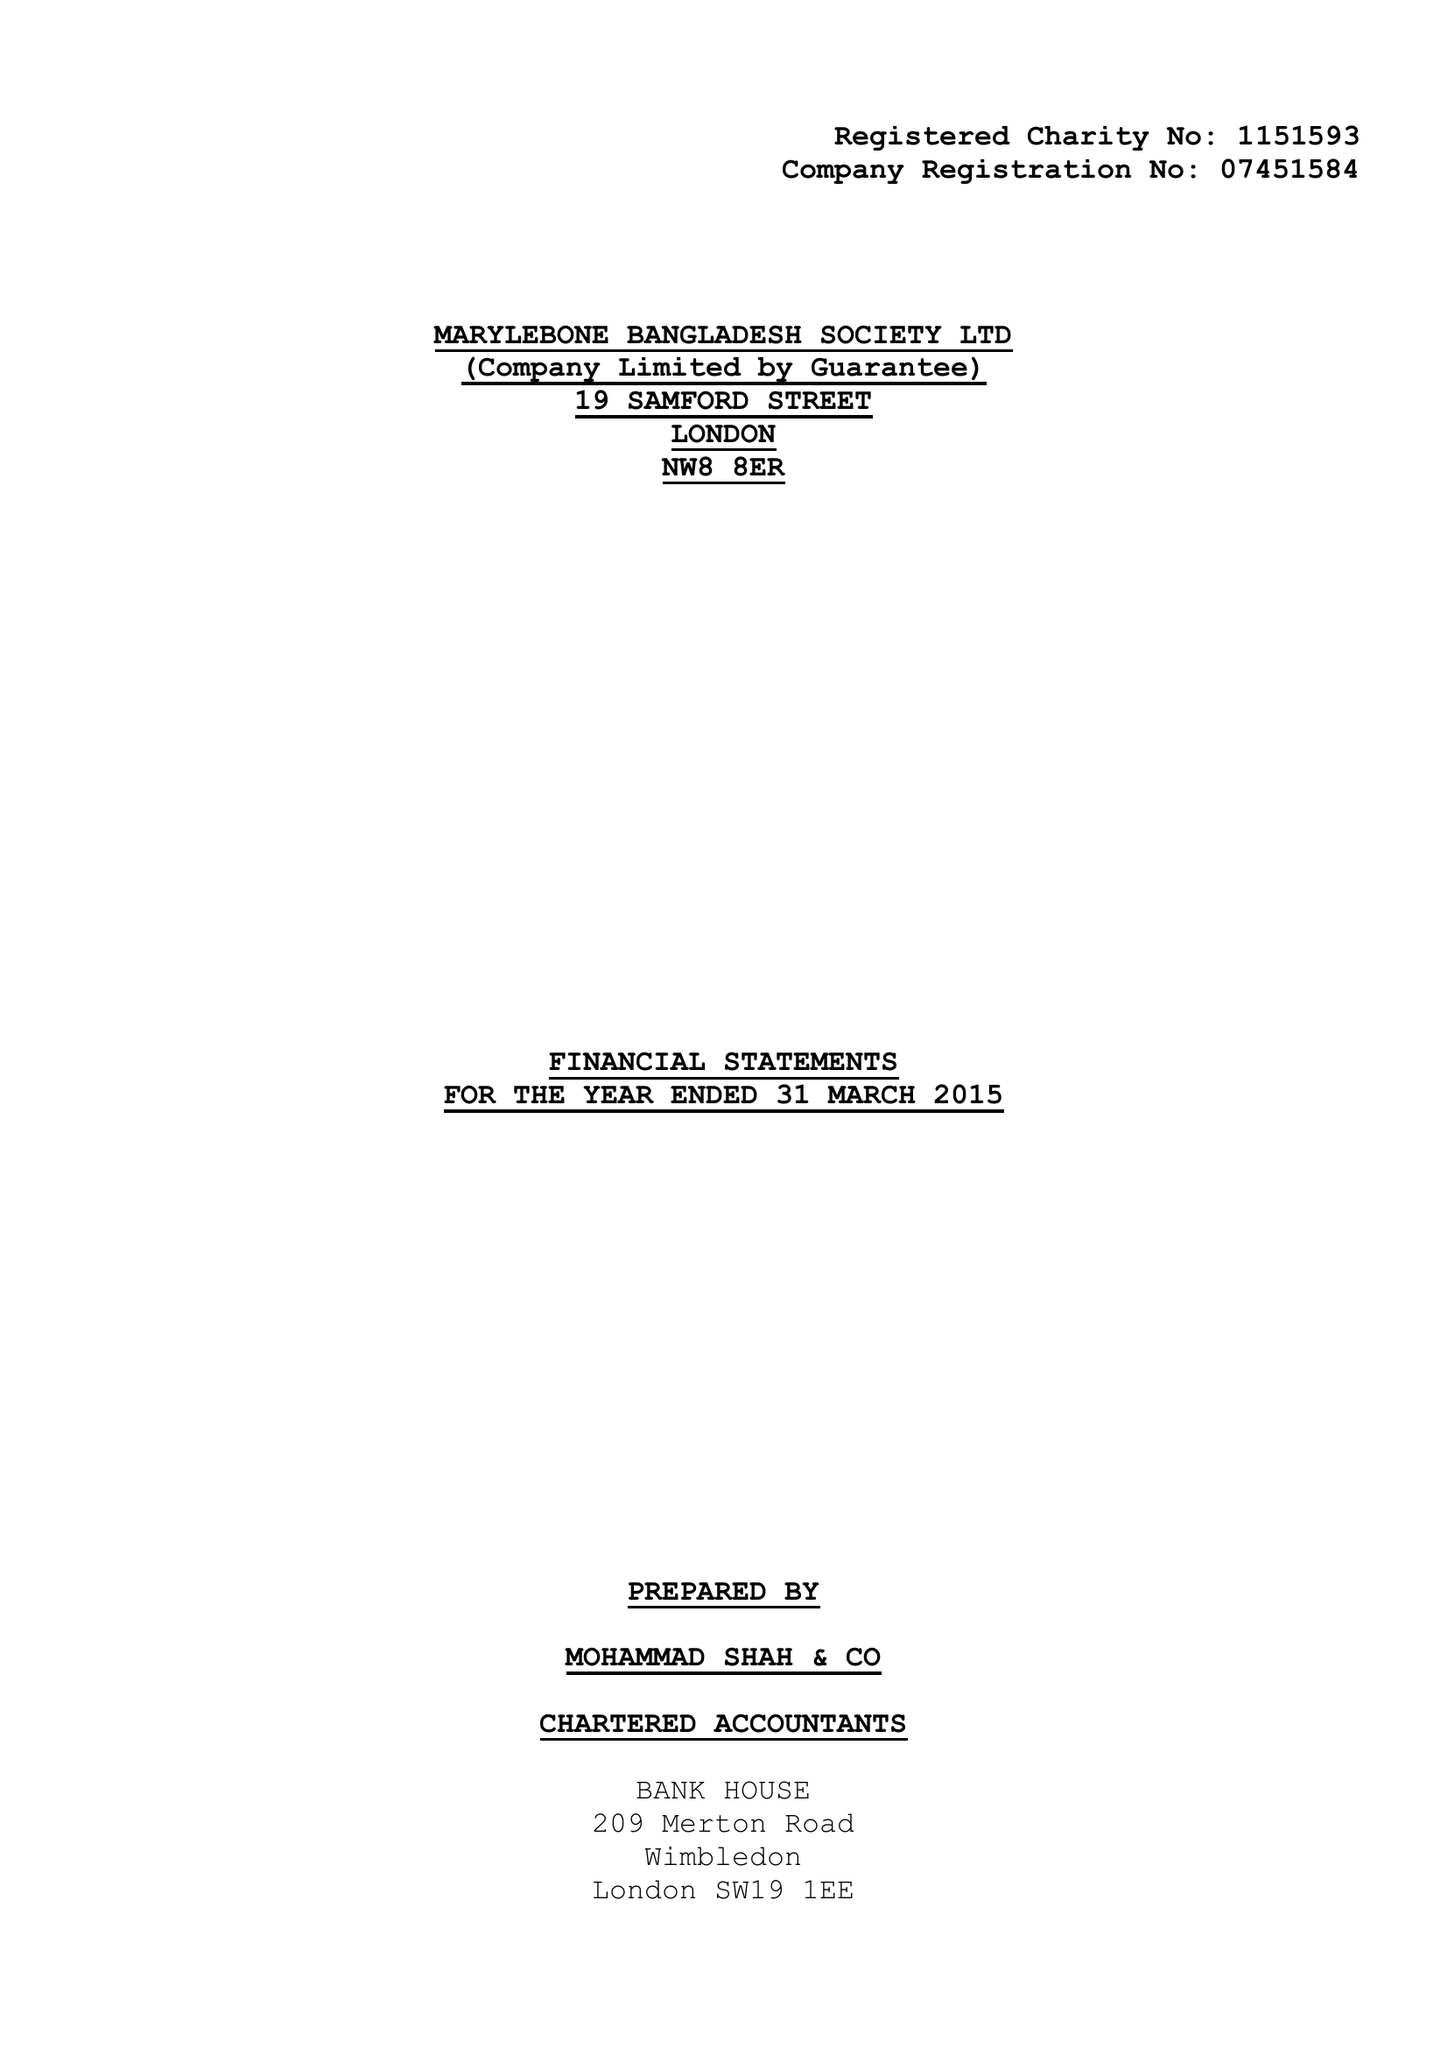What is the value for the spending_annually_in_british_pounds?
Answer the question using a single word or phrase. 168571.00 